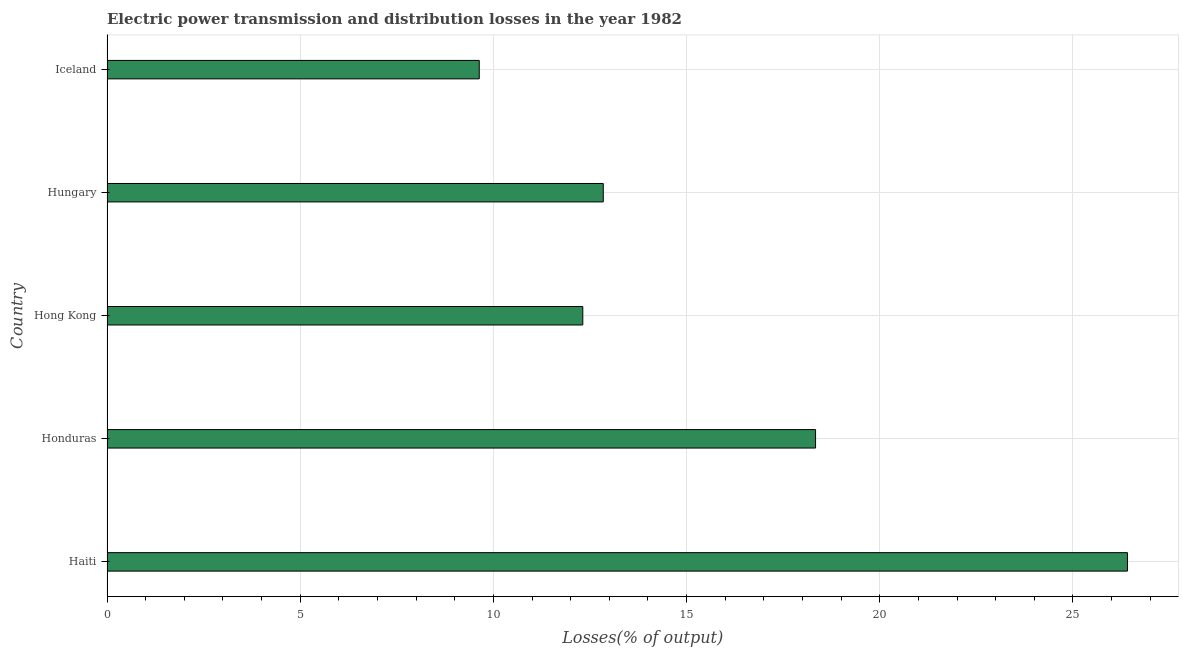What is the title of the graph?
Offer a terse response. Electric power transmission and distribution losses in the year 1982. What is the label or title of the X-axis?
Provide a short and direct response. Losses(% of output). What is the label or title of the Y-axis?
Offer a very short reply. Country. What is the electric power transmission and distribution losses in Honduras?
Your response must be concise. 18.34. Across all countries, what is the maximum electric power transmission and distribution losses?
Ensure brevity in your answer.  26.41. Across all countries, what is the minimum electric power transmission and distribution losses?
Ensure brevity in your answer.  9.63. In which country was the electric power transmission and distribution losses maximum?
Keep it short and to the point. Haiti. What is the sum of the electric power transmission and distribution losses?
Give a very brief answer. 79.54. What is the difference between the electric power transmission and distribution losses in Hungary and Iceland?
Your response must be concise. 3.21. What is the average electric power transmission and distribution losses per country?
Ensure brevity in your answer.  15.91. What is the median electric power transmission and distribution losses?
Provide a succinct answer. 12.84. In how many countries, is the electric power transmission and distribution losses greater than 16 %?
Offer a terse response. 2. What is the ratio of the electric power transmission and distribution losses in Hungary to that in Iceland?
Your response must be concise. 1.33. What is the difference between the highest and the second highest electric power transmission and distribution losses?
Offer a terse response. 8.07. Is the sum of the electric power transmission and distribution losses in Hungary and Iceland greater than the maximum electric power transmission and distribution losses across all countries?
Your response must be concise. No. What is the difference between the highest and the lowest electric power transmission and distribution losses?
Ensure brevity in your answer.  16.78. In how many countries, is the electric power transmission and distribution losses greater than the average electric power transmission and distribution losses taken over all countries?
Offer a terse response. 2. How many countries are there in the graph?
Offer a terse response. 5. Are the values on the major ticks of X-axis written in scientific E-notation?
Make the answer very short. No. What is the Losses(% of output) of Haiti?
Offer a terse response. 26.41. What is the Losses(% of output) of Honduras?
Provide a short and direct response. 18.34. What is the Losses(% of output) in Hong Kong?
Your response must be concise. 12.31. What is the Losses(% of output) in Hungary?
Your response must be concise. 12.84. What is the Losses(% of output) of Iceland?
Offer a very short reply. 9.63. What is the difference between the Losses(% of output) in Haiti and Honduras?
Keep it short and to the point. 8.07. What is the difference between the Losses(% of output) in Haiti and Hong Kong?
Your answer should be very brief. 14.1. What is the difference between the Losses(% of output) in Haiti and Hungary?
Make the answer very short. 13.57. What is the difference between the Losses(% of output) in Haiti and Iceland?
Give a very brief answer. 16.78. What is the difference between the Losses(% of output) in Honduras and Hong Kong?
Your response must be concise. 6.02. What is the difference between the Losses(% of output) in Honduras and Hungary?
Offer a terse response. 5.49. What is the difference between the Losses(% of output) in Honduras and Iceland?
Your answer should be compact. 8.7. What is the difference between the Losses(% of output) in Hong Kong and Hungary?
Offer a terse response. -0.53. What is the difference between the Losses(% of output) in Hong Kong and Iceland?
Offer a very short reply. 2.68. What is the difference between the Losses(% of output) in Hungary and Iceland?
Make the answer very short. 3.21. What is the ratio of the Losses(% of output) in Haiti to that in Honduras?
Make the answer very short. 1.44. What is the ratio of the Losses(% of output) in Haiti to that in Hong Kong?
Ensure brevity in your answer.  2.15. What is the ratio of the Losses(% of output) in Haiti to that in Hungary?
Your answer should be compact. 2.06. What is the ratio of the Losses(% of output) in Haiti to that in Iceland?
Ensure brevity in your answer.  2.74. What is the ratio of the Losses(% of output) in Honduras to that in Hong Kong?
Ensure brevity in your answer.  1.49. What is the ratio of the Losses(% of output) in Honduras to that in Hungary?
Offer a terse response. 1.43. What is the ratio of the Losses(% of output) in Honduras to that in Iceland?
Your answer should be compact. 1.9. What is the ratio of the Losses(% of output) in Hong Kong to that in Iceland?
Your answer should be compact. 1.28. What is the ratio of the Losses(% of output) in Hungary to that in Iceland?
Make the answer very short. 1.33. 